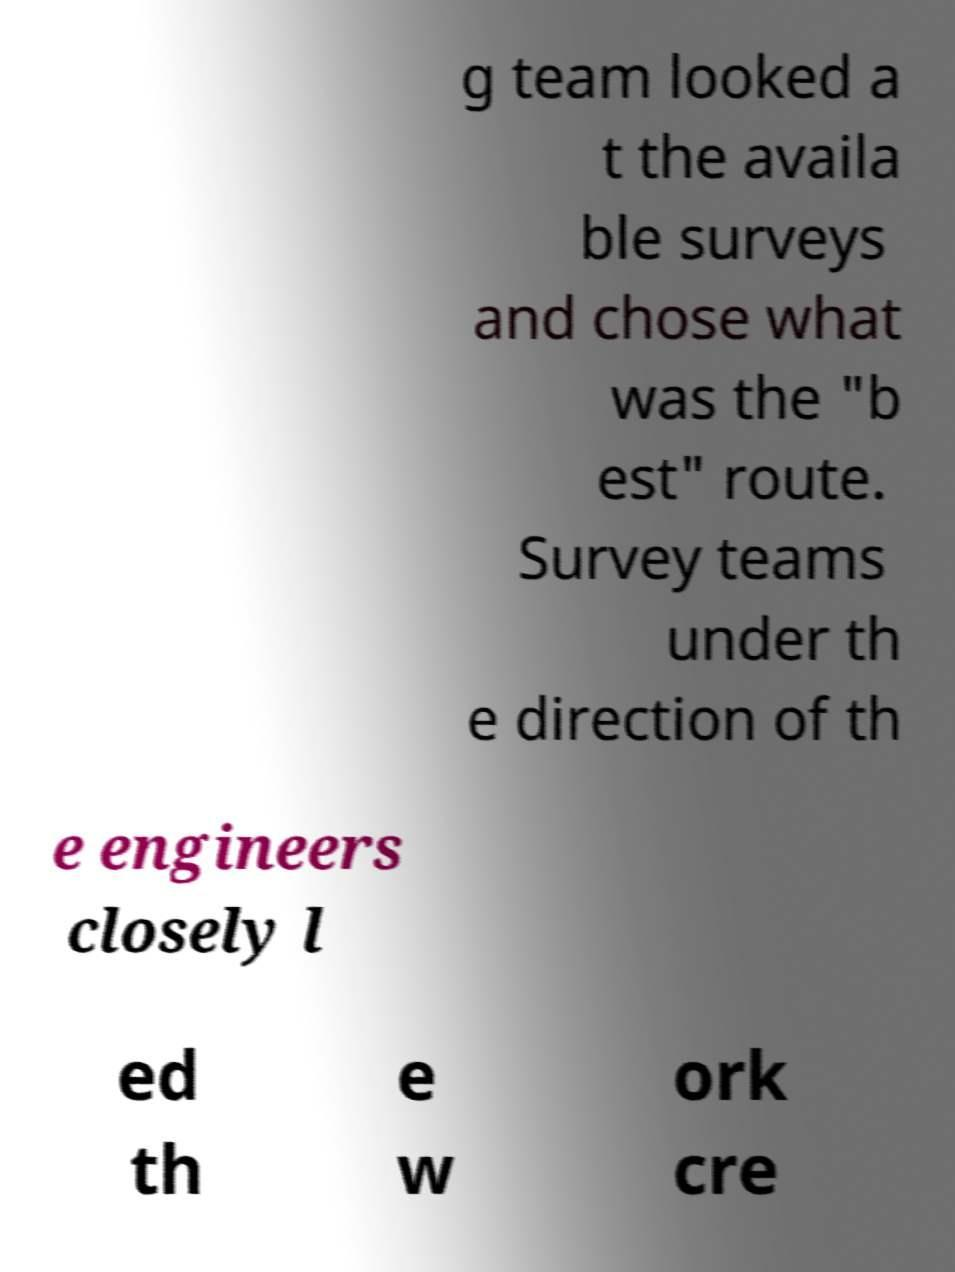There's text embedded in this image that I need extracted. Can you transcribe it verbatim? g team looked a t the availa ble surveys and chose what was the "b est" route. Survey teams under th e direction of th e engineers closely l ed th e w ork cre 